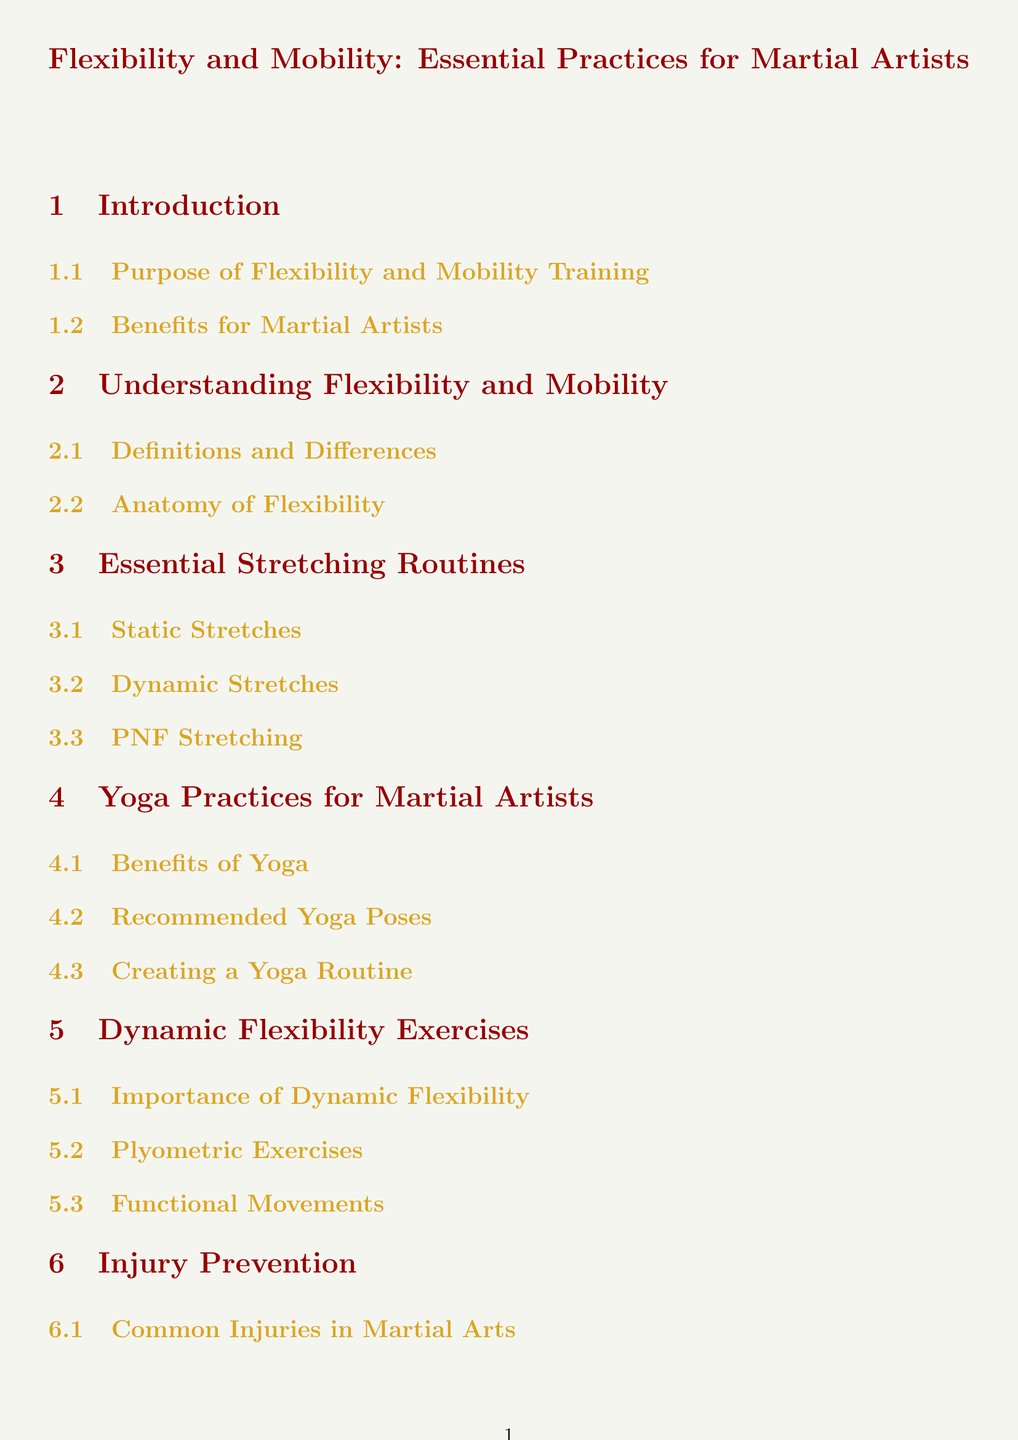What is the purpose of flexibility and mobility training? The purpose of flexibility and mobility training is outlined in the introduction section of the document.
Answer: Purpose of Flexibility and Mobility Training What are the benefits of yoga for martial artists? The benefits of yoga are detailed in the yoga practices section of the document.
Answer: Benefits of Yoga How many types of stretching routines are mentioned? The essential stretching routines section lists three types, thus requiring the reader to count them.
Answer: Three What is PNF stretching? The term is listed under the essential stretching routines and is described at that subsection.
Answer: PNF Stretching What is one common injury in martial arts? Common injuries in martial arts are discussed in the injury prevention section of the document.
Answer: Common Injuries in Martial Arts When discussing injury prevention, what does stretching help with? The document indicates that stretching aids in injury prevention as discussed in the respective subsection.
Answer: Stretching as Injury Prevention What is a key point discussed in the conclusion? The conclusion section recaps the key points of the document.
Answer: Recap of Key Points What types of resources are listed in the additional resources section? The additional resources section mentions specific types of resources available for further learning.
Answer: Books and Articles What are plyometric exercises important for? The importance of dynamic flexibility, which includes plyometric exercises, is explained in the dynamic flexibility exercises section.
Answer: Importance of Dynamic Flexibility 